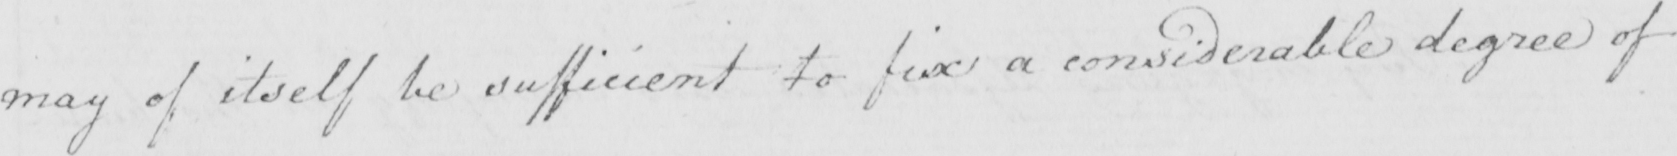Transcribe the text shown in this historical manuscript line. may of itself be sufficient to fix a considerable degree of 